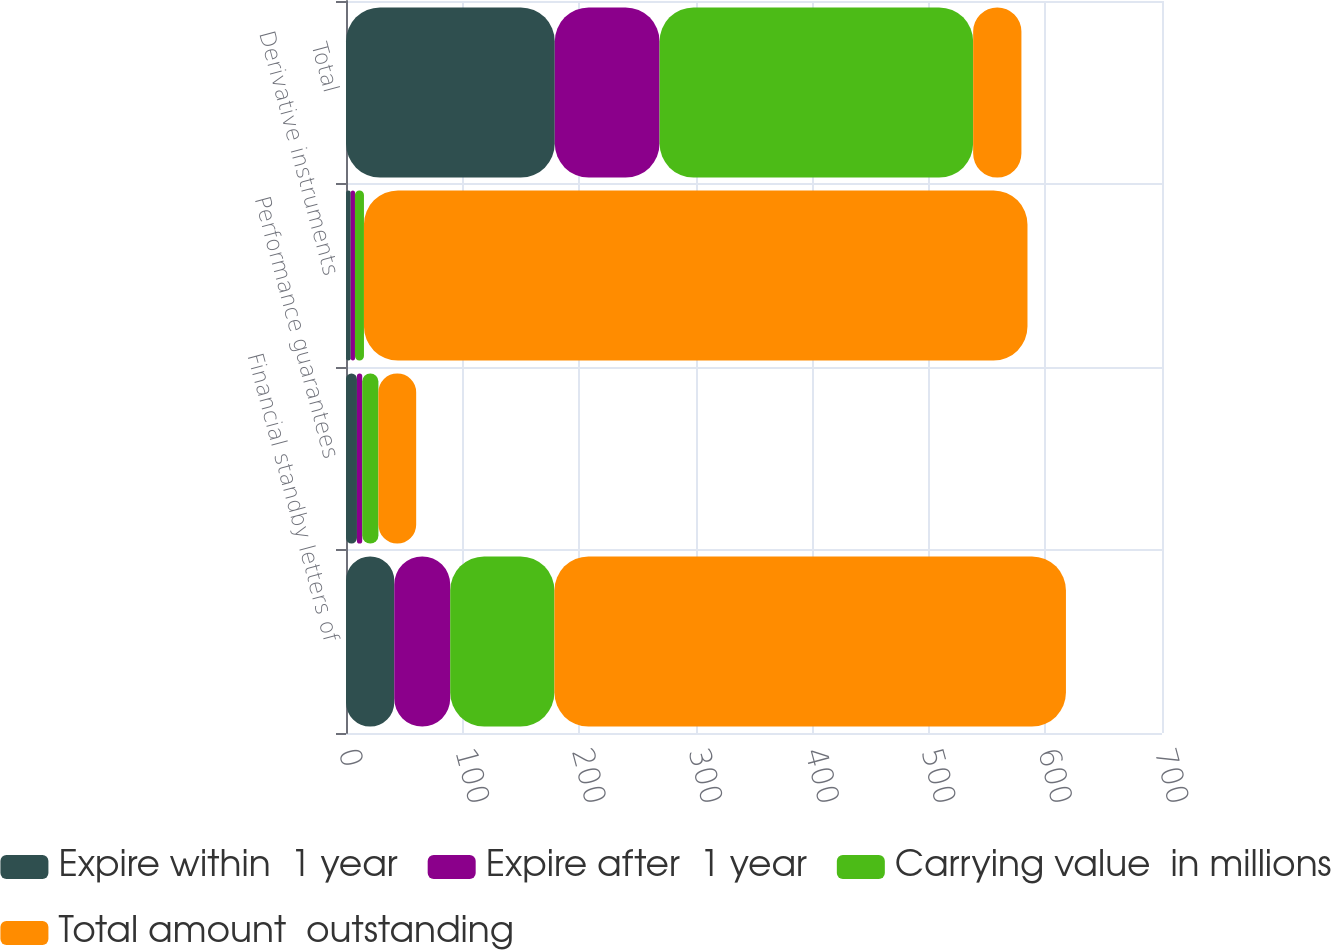Convert chart to OTSL. <chart><loc_0><loc_0><loc_500><loc_500><stacked_bar_chart><ecel><fcel>Financial standby letters of<fcel>Performance guarantees<fcel>Derivative instruments<fcel>Total<nl><fcel>Expire within  1 year<fcel>41.4<fcel>9.4<fcel>4.1<fcel>179.1<nl><fcel>Expire after  1 year<fcel>48<fcel>4.5<fcel>3.6<fcel>89.9<nl><fcel>Carrying value  in millions<fcel>89.4<fcel>13.9<fcel>7.7<fcel>269<nl><fcel>Total amount  outstanding<fcel>438.8<fcel>32.4<fcel>569.2<fcel>41.4<nl></chart> 